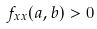<formula> <loc_0><loc_0><loc_500><loc_500>f _ { x x } ( a , b ) > 0</formula> 